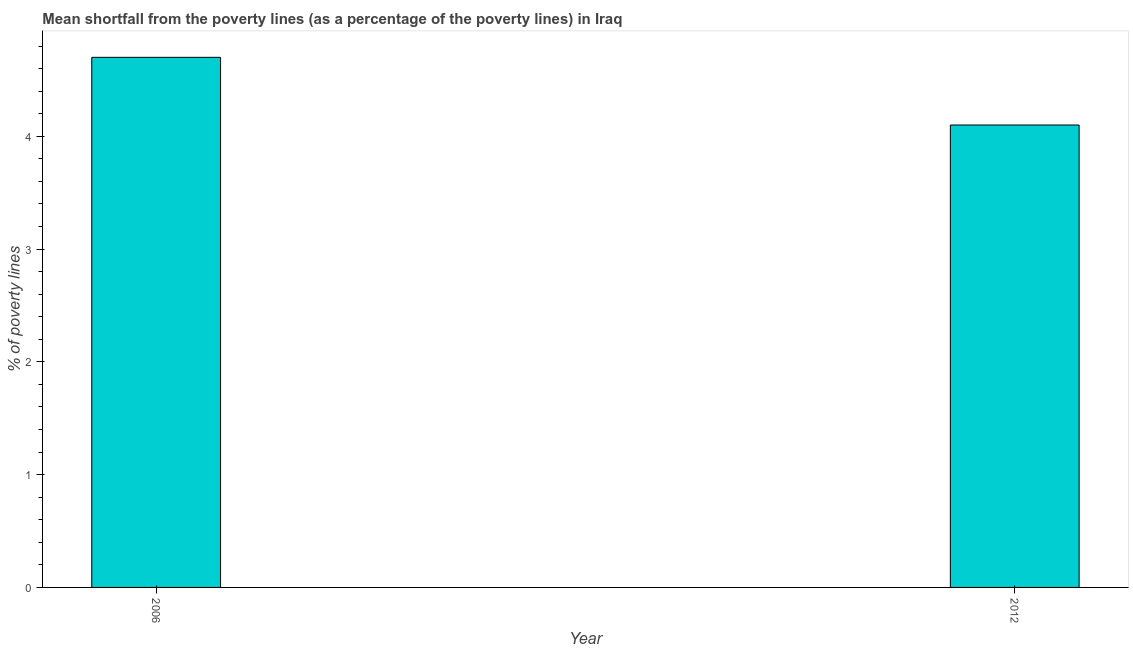Does the graph contain any zero values?
Your answer should be very brief. No. What is the title of the graph?
Provide a succinct answer. Mean shortfall from the poverty lines (as a percentage of the poverty lines) in Iraq. What is the label or title of the X-axis?
Your answer should be compact. Year. What is the label or title of the Y-axis?
Offer a very short reply. % of poverty lines. Across all years, what is the minimum poverty gap at national poverty lines?
Provide a short and direct response. 4.1. In which year was the poverty gap at national poverty lines maximum?
Offer a terse response. 2006. In which year was the poverty gap at national poverty lines minimum?
Offer a very short reply. 2012. What is the average poverty gap at national poverty lines per year?
Keep it short and to the point. 4.4. Do a majority of the years between 2006 and 2012 (inclusive) have poverty gap at national poverty lines greater than 3.8 %?
Keep it short and to the point. Yes. What is the ratio of the poverty gap at national poverty lines in 2006 to that in 2012?
Keep it short and to the point. 1.15. Is the poverty gap at national poverty lines in 2006 less than that in 2012?
Your response must be concise. No. In how many years, is the poverty gap at national poverty lines greater than the average poverty gap at national poverty lines taken over all years?
Offer a very short reply. 1. How many bars are there?
Make the answer very short. 2. How many years are there in the graph?
Make the answer very short. 2. Are the values on the major ticks of Y-axis written in scientific E-notation?
Ensure brevity in your answer.  No. What is the % of poverty lines in 2006?
Your response must be concise. 4.7. What is the ratio of the % of poverty lines in 2006 to that in 2012?
Your answer should be compact. 1.15. 